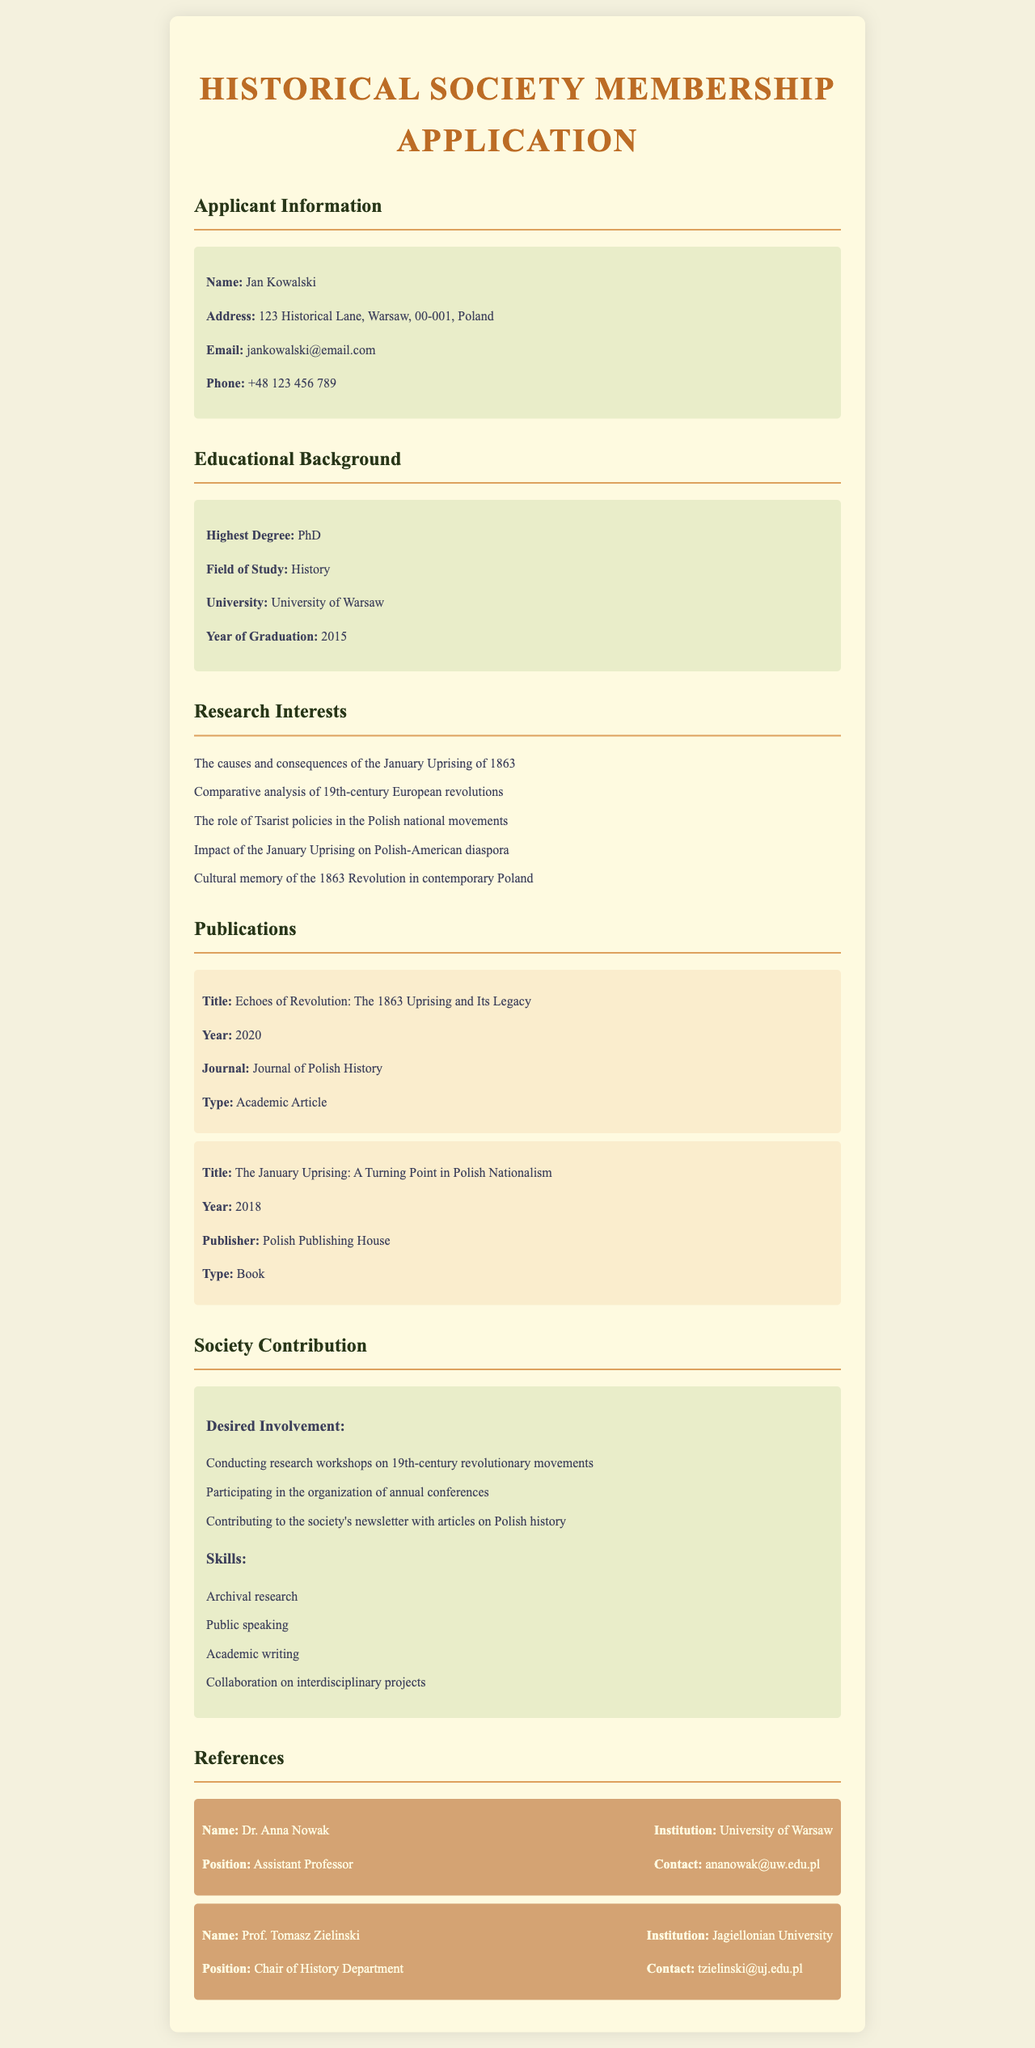What is the applicant's name? The name of the applicant is clearly stated in the document.
Answer: Jan Kowalski What is the highest degree attained by the applicant? The applicant's educational background specifies the highest degree.
Answer: PhD In which year did the applicant graduate? The document provides the year of graduation for the applicant's educational background.
Answer: 2015 What is one of the applicant's research interests? The document lists multiple research interests of the applicant.
Answer: The causes and consequences of the January Uprising of 1863 What type of publication did the applicant write in 2020? The document specifies the type of publication for each entry listed.
Answer: Academic Article What is one desired involvement of the applicant in the society? The document lists several ways the applicant wishes to contribute to the society.
Answer: Conducting research workshops on 19th-century revolutionary movements Who is one of the references provided by the applicant? The document includes names of the references along with their affiliations.
Answer: Dr. Anna Nowak What is the position of Prof. Tomasz Zielinski? The document states the position of each reference clearly.
Answer: Chair of History Department 